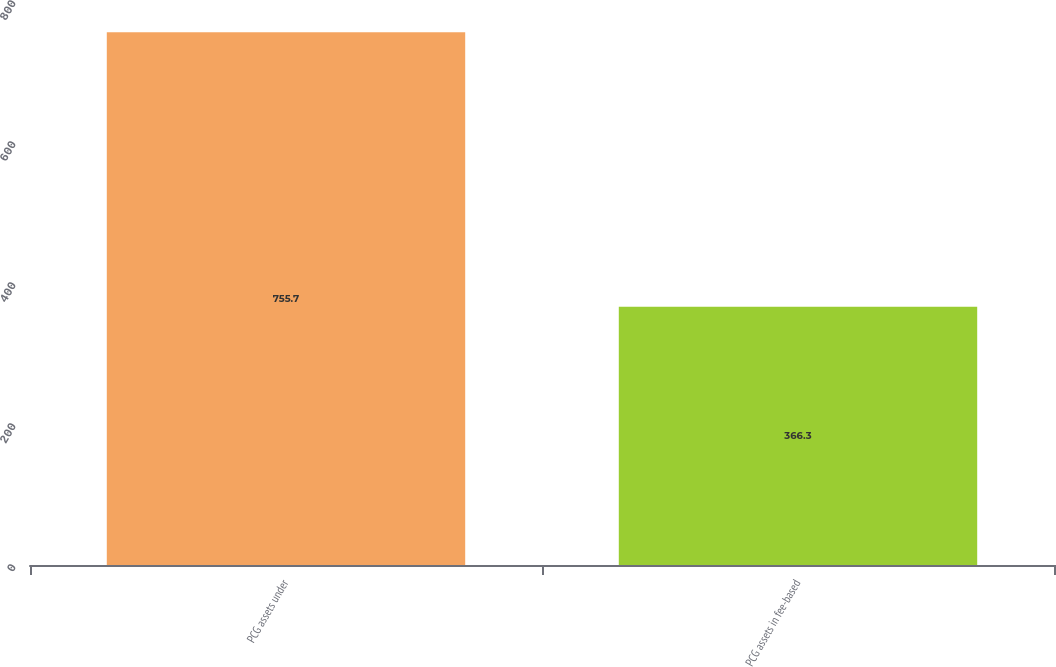Convert chart to OTSL. <chart><loc_0><loc_0><loc_500><loc_500><bar_chart><fcel>PCG assets under<fcel>PCG assets in fee-based<nl><fcel>755.7<fcel>366.3<nl></chart> 